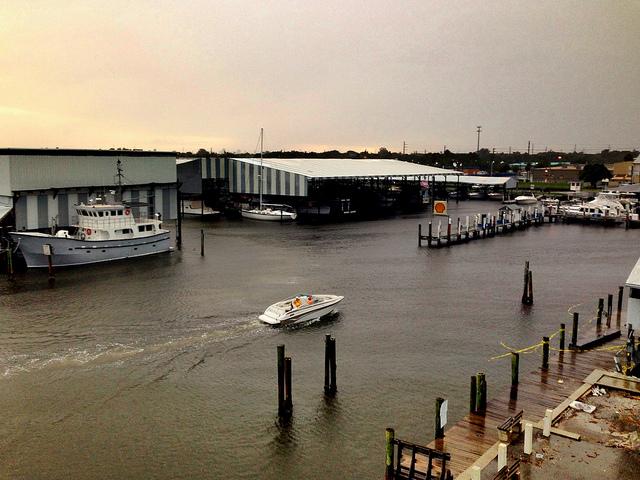Can you go swimming at this location?
Short answer required. No. What does the blue building say?
Answer briefly. Nothing. How would you describe the water?
Short answer required. Murky. Is the water wavy?
Give a very brief answer. No. Are they sitting on a pier?
Answer briefly. No. How many boats are in the photo?
Quick response, please. 5. Do the boats pull right up to buildings?
Concise answer only. Yes. What kind of boat is pictured?
Be succinct. Speed boat. What is in the water?
Answer briefly. Boats. What is the most weathered looking?
Be succinct. Dock. 